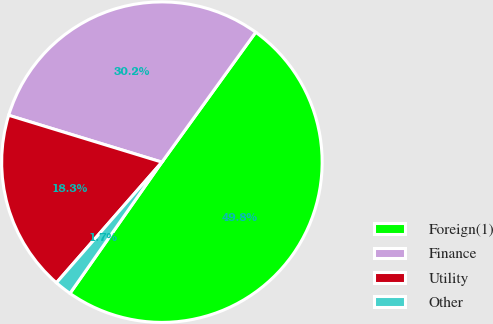Convert chart to OTSL. <chart><loc_0><loc_0><loc_500><loc_500><pie_chart><fcel>Foreign(1)<fcel>Finance<fcel>Utility<fcel>Other<nl><fcel>49.77%<fcel>30.23%<fcel>18.29%<fcel>1.71%<nl></chart> 